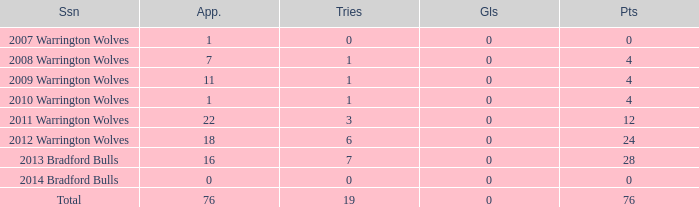How many times is tries 0 and appearance less than 0? 0.0. 